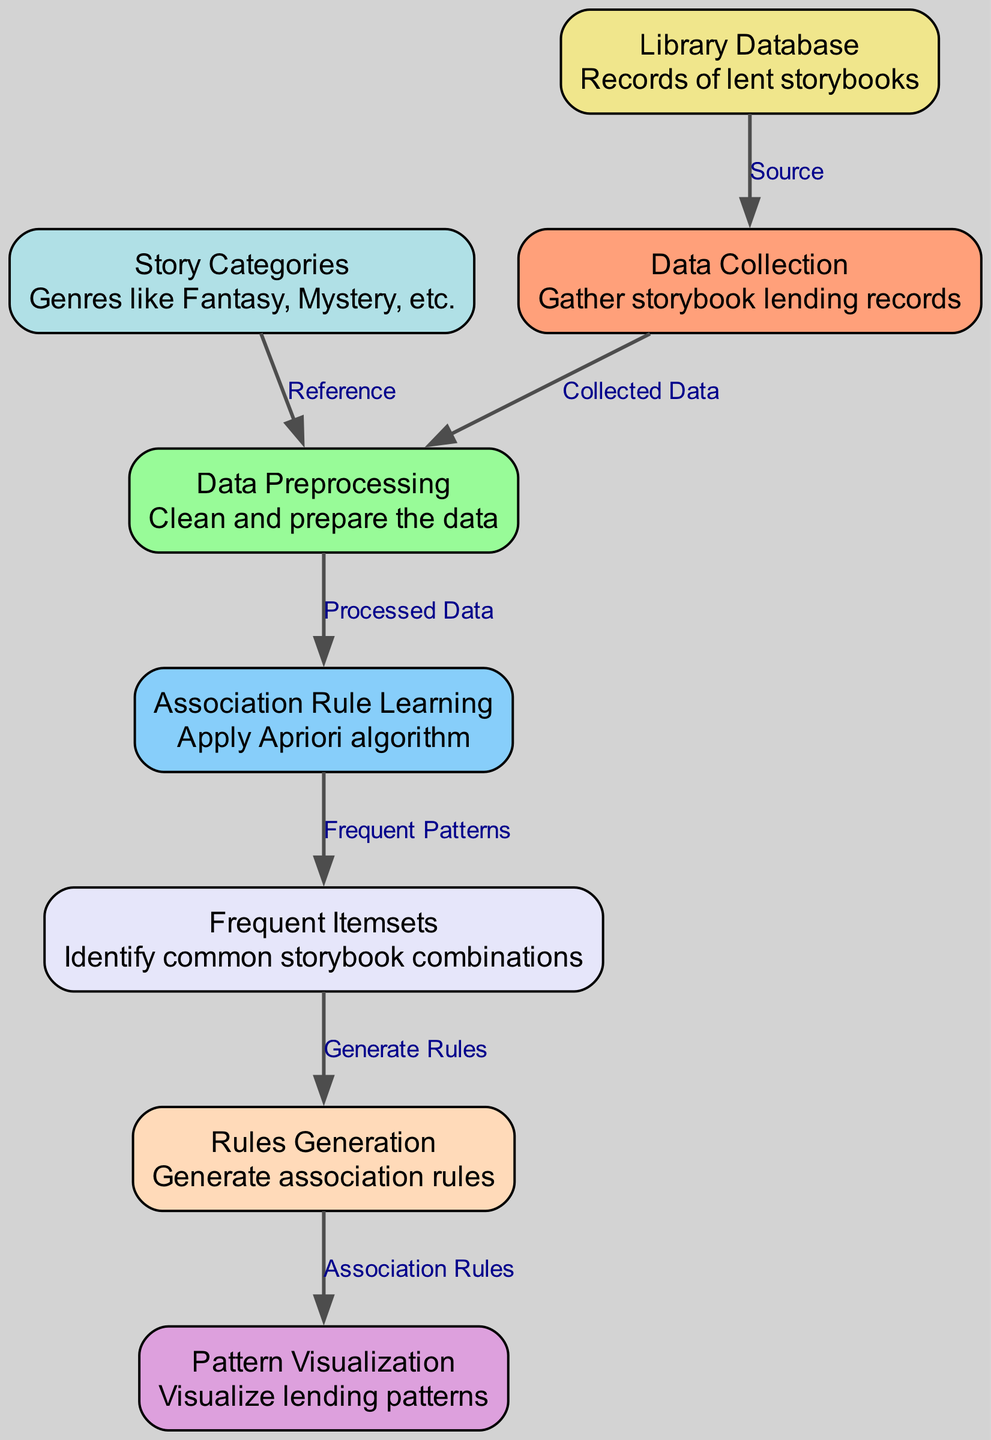What is the first step in the process? The diagram shows that the first step is "Data Collection," which is represented as the initial node in the sequence. This node has an incoming edge from "Library Database," indicating that the data is gathered from this source.
Answer: Data Collection How many nodes are present in the diagram? By counting the nodes listed in the JSON data, there are a total of eight distinct nodes, each fulfilling a different role in the process of lending storybooks.
Answer: 8 Which node follows "Data Preprocessing"? The diagram indicates that "Association Rule Learning" directly follows "Data Preprocessing," as there is an edge leading from "Data Preprocessing" to this node.
Answer: Association Rule Learning What type of algorithm is applied in the "Association Rule Learning" step? The diagram specifies that the Apriori algorithm is used in the "Association Rule Learning" step, as this information is included in the node's description.
Answer: Apriori What are the output results of "Frequent Itemsets"? The output of "Frequent Itemsets" leads to "Rules Generation," implying that it produces common combinations of storybooks that are then used to create association rules.
Answer: Rules Generation Which two nodes are directly connected by an edge? The nodes "Data Collection" and "Data Preprocessing" are directly connected by an edge labeled "Collected Data," indicating the flow from one step to the next.
Answer: Data Collection and Data Preprocessing How does "Story Categories" relate to the process? "Story Categories" serves as a reference point for the "Data Preprocessing" step, suggesting that genres of the storybooks are utilized for cleaning and preparing the data.
Answer: Reference What do "Frequent Itemsets" lead to in the diagram? "Frequent Itemsets" generate "Rules Generation," establishing a connection where frequent patterns become the basis for creating associative rules that are later visualized.
Answer: Rules Generation What visualization aspect is highlighted in the last step of the diagram? The last step of the diagram indicates "Pattern Visualization," which focuses on displaying the lending patterns derived from the previous steps, specifically from the generated rules.
Answer: Pattern Visualization 